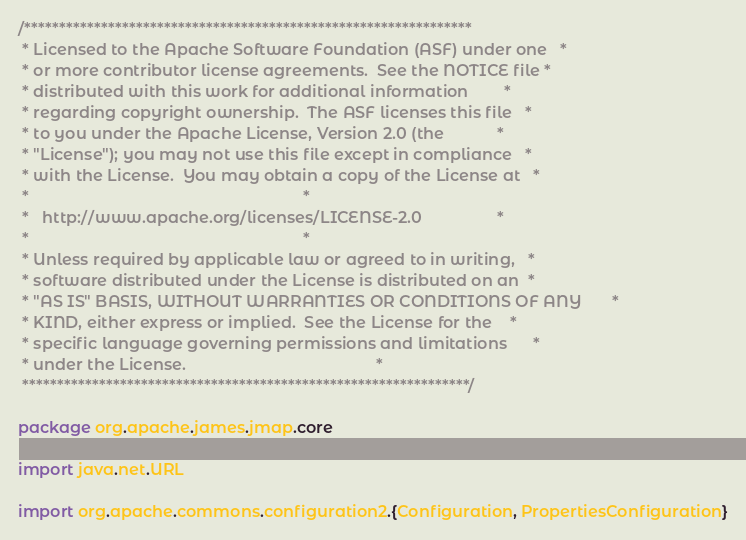<code> <loc_0><loc_0><loc_500><loc_500><_Scala_>/****************************************************************
 * Licensed to the Apache Software Foundation (ASF) under one   *
 * or more contributor license agreements.  See the NOTICE file *
 * distributed with this work for additional information        *
 * regarding copyright ownership.  The ASF licenses this file   *
 * to you under the Apache License, Version 2.0 (the            *
 * "License"); you may not use this file except in compliance   *
 * with the License.  You may obtain a copy of the License at   *
 *                                                              *
 *   http://www.apache.org/licenses/LICENSE-2.0                 *
 *                                                              *
 * Unless required by applicable law or agreed to in writing,   *
 * software distributed under the License is distributed on an  *
 * "AS IS" BASIS, WITHOUT WARRANTIES OR CONDITIONS OF ANY       *
 * KIND, either express or implied.  See the License for the    *
 * specific language governing permissions and limitations      *
 * under the License.                                           *
 ****************************************************************/

package org.apache.james.jmap.core

import java.net.URL

import org.apache.commons.configuration2.{Configuration, PropertiesConfiguration}</code> 